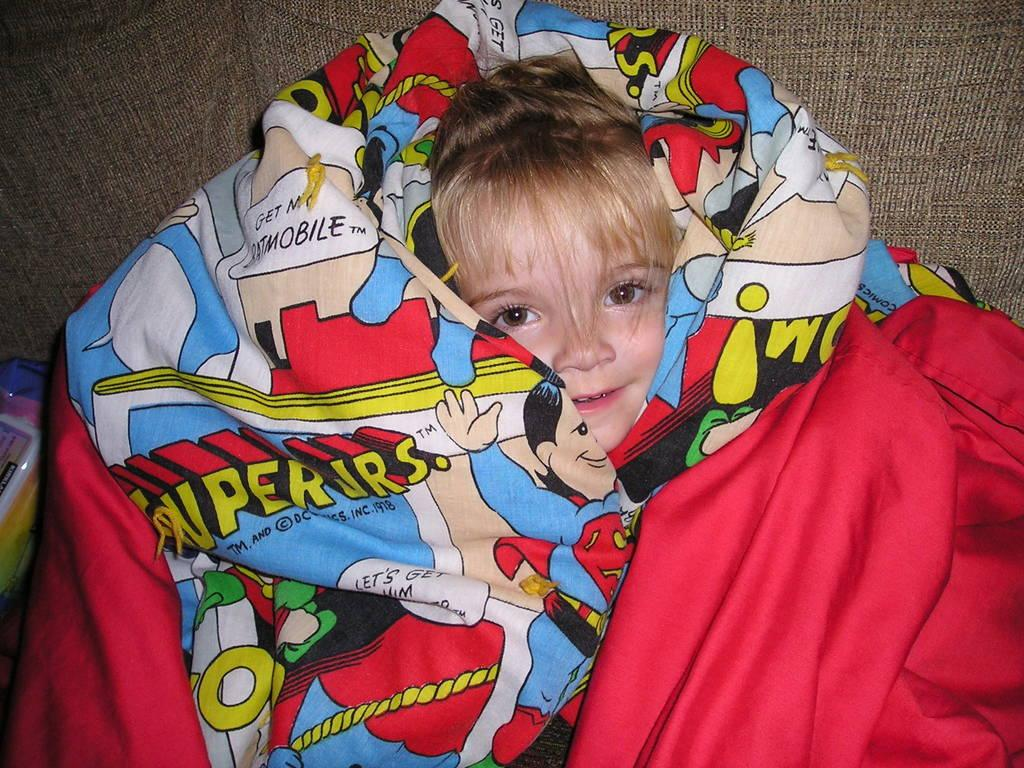Who is the main subject in the image? There is a girl in the image. What is the girl wearing or wrapped in? The girl is wrapped in a cartoon blanket. How many toes can be seen on the girl's feet in the image? There is no information about the girl's toes in the image, so it cannot be determined. 